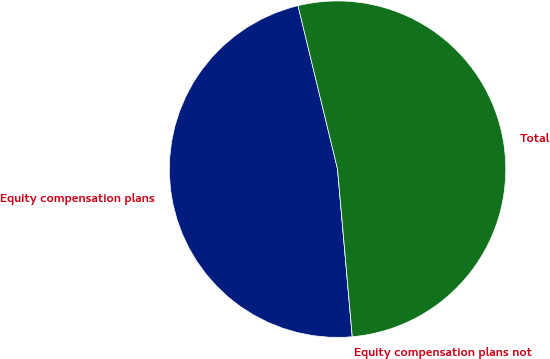<chart> <loc_0><loc_0><loc_500><loc_500><pie_chart><fcel>Equity compensation plans<fcel>Equity compensation plans not<fcel>Total<nl><fcel>47.62%<fcel>0.0%<fcel>52.38%<nl></chart> 